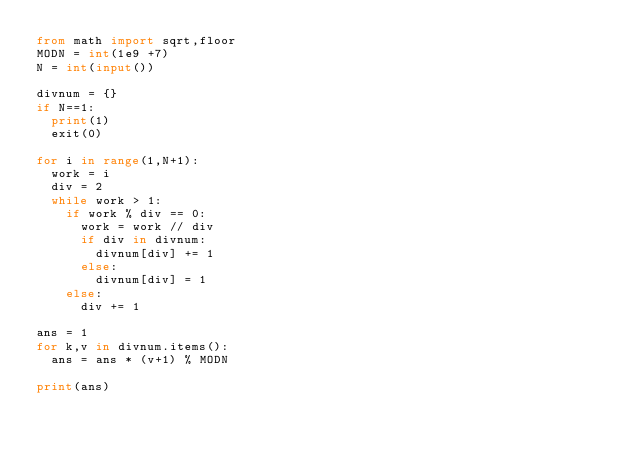<code> <loc_0><loc_0><loc_500><loc_500><_Python_>from math import sqrt,floor
MODN = int(1e9 +7)
N = int(input())

divnum = {}
if N==1:
  print(1)
  exit(0)
  
for i in range(1,N+1):
  work = i
  div = 2
  while work > 1:
    if work % div == 0:
      work = work // div
      if div in divnum:
        divnum[div] += 1
      else:
        divnum[div] = 1
    else:
      div += 1

ans = 1
for k,v in divnum.items():
  ans = ans * (v+1) % MODN
  
print(ans)</code> 